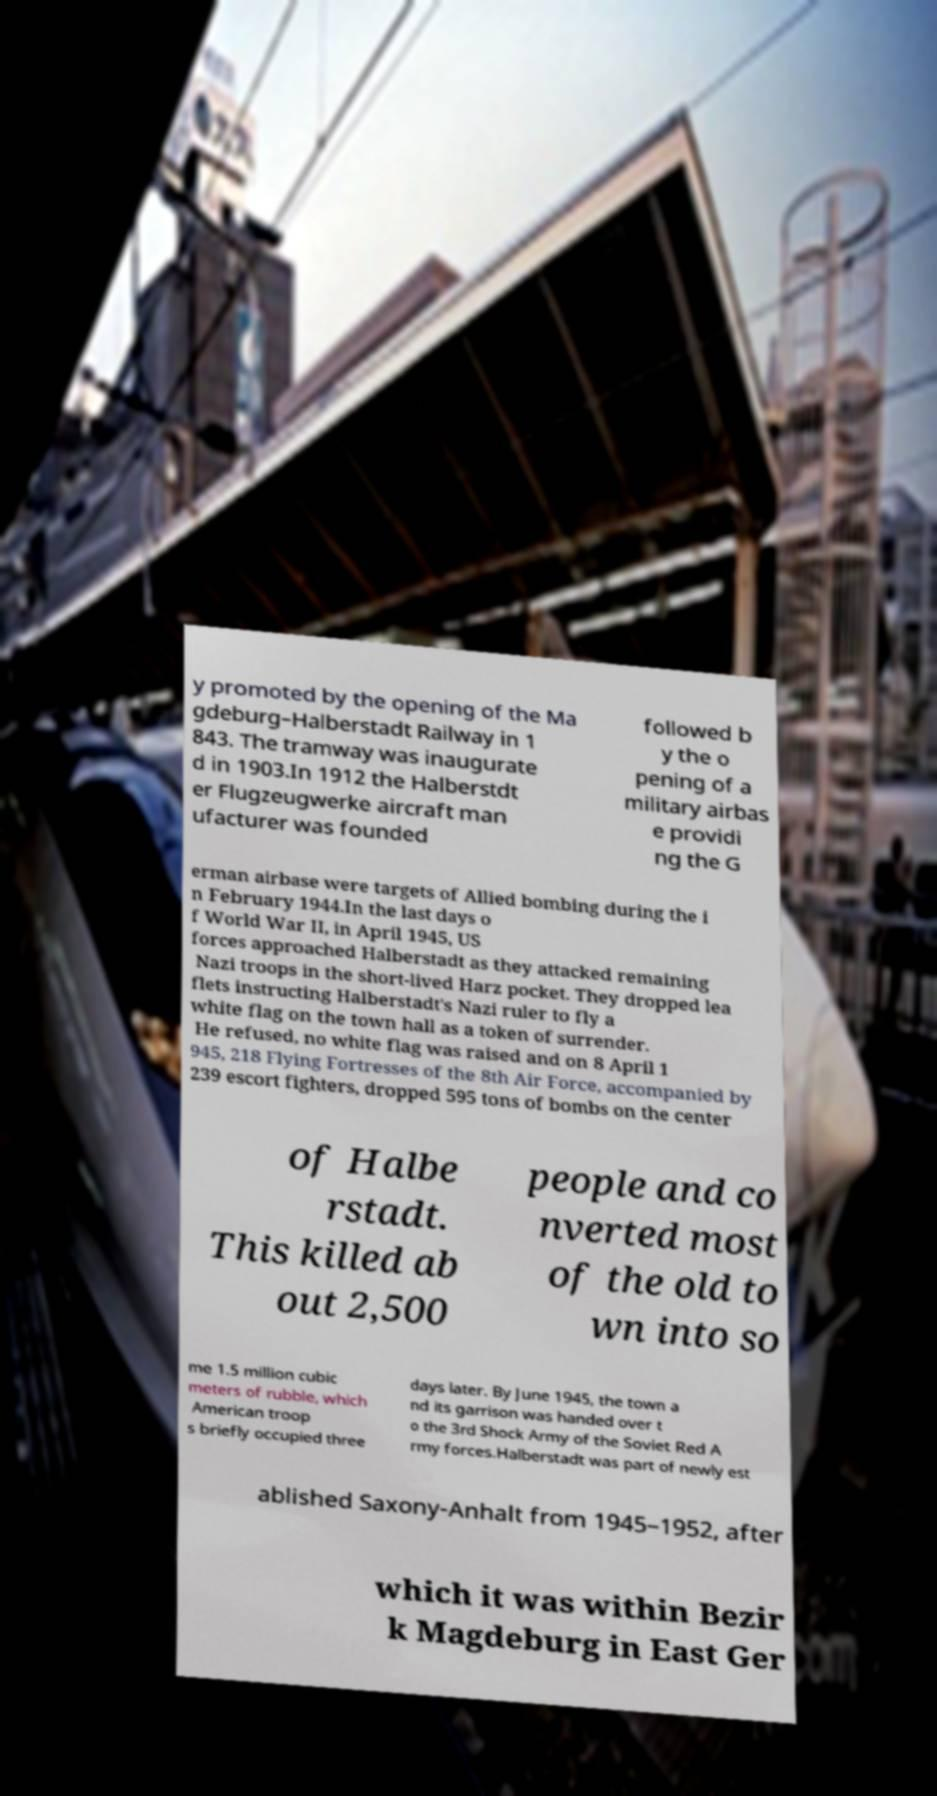I need the written content from this picture converted into text. Can you do that? y promoted by the opening of the Ma gdeburg–Halberstadt Railway in 1 843. The tramway was inaugurate d in 1903.In 1912 the Halberstdt er Flugzeugwerke aircraft man ufacturer was founded followed b y the o pening of a military airbas e providi ng the G erman airbase were targets of Allied bombing during the i n February 1944.In the last days o f World War II, in April 1945, US forces approached Halberstadt as they attacked remaining Nazi troops in the short-lived Harz pocket. They dropped lea flets instructing Halberstadt's Nazi ruler to fly a white flag on the town hall as a token of surrender. He refused, no white flag was raised and on 8 April 1 945, 218 Flying Fortresses of the 8th Air Force, accompanied by 239 escort fighters, dropped 595 tons of bombs on the center of Halbe rstadt. This killed ab out 2,500 people and co nverted most of the old to wn into so me 1.5 million cubic meters of rubble, which American troop s briefly occupied three days later. By June 1945, the town a nd its garrison was handed over t o the 3rd Shock Army of the Soviet Red A rmy forces.Halberstadt was part of newly est ablished Saxony-Anhalt from 1945–1952, after which it was within Bezir k Magdeburg in East Ger 